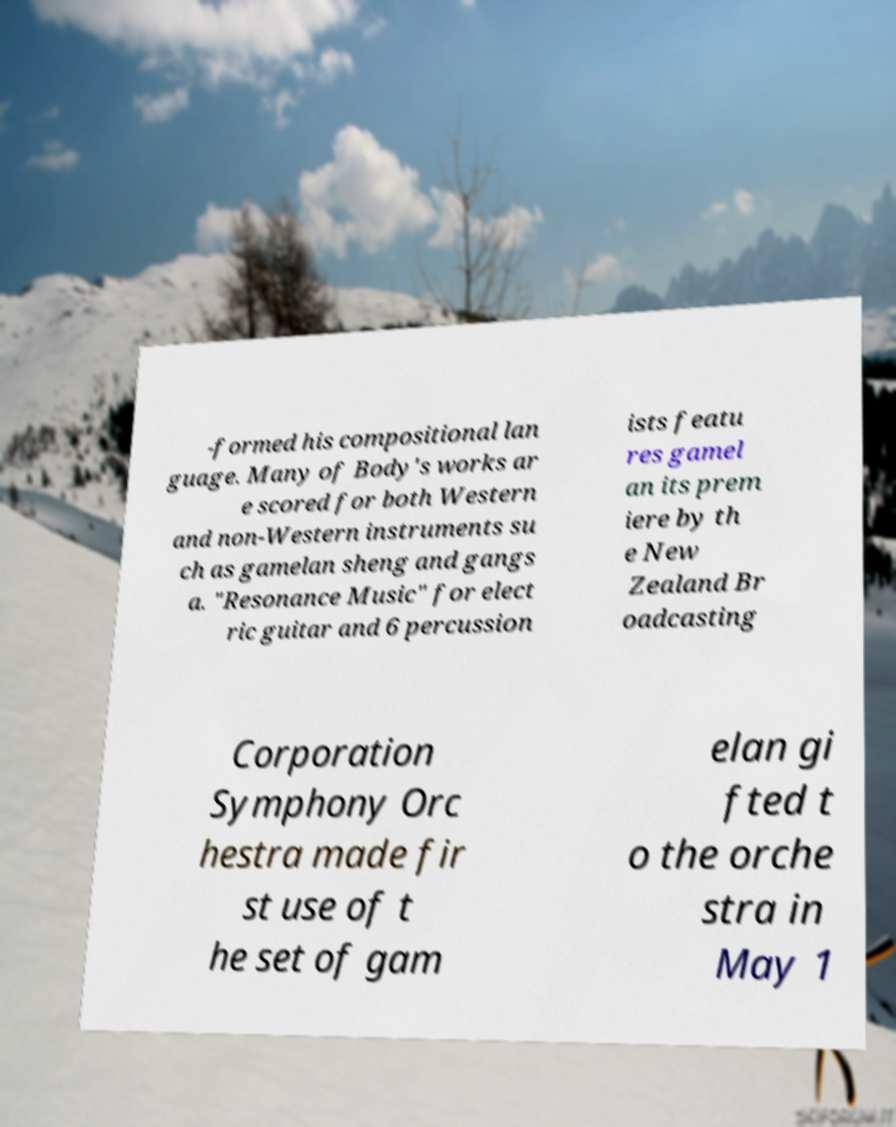For documentation purposes, I need the text within this image transcribed. Could you provide that? -formed his compositional lan guage. Many of Body's works ar e scored for both Western and non-Western instruments su ch as gamelan sheng and gangs a. "Resonance Music" for elect ric guitar and 6 percussion ists featu res gamel an its prem iere by th e New Zealand Br oadcasting Corporation Symphony Orc hestra made fir st use of t he set of gam elan gi fted t o the orche stra in May 1 